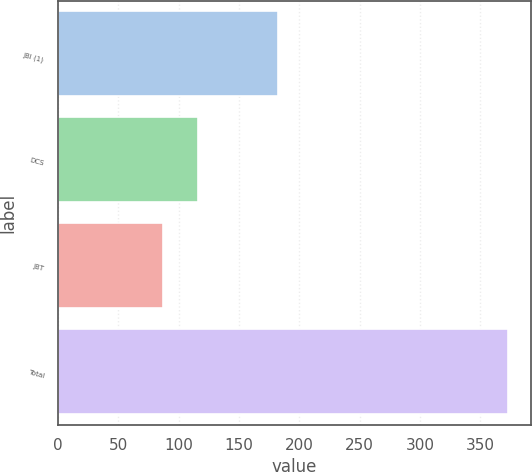<chart> <loc_0><loc_0><loc_500><loc_500><bar_chart><fcel>JBI (1)<fcel>DCS<fcel>JBT<fcel>Total<nl><fcel>182<fcel>115.6<fcel>87<fcel>373<nl></chart> 